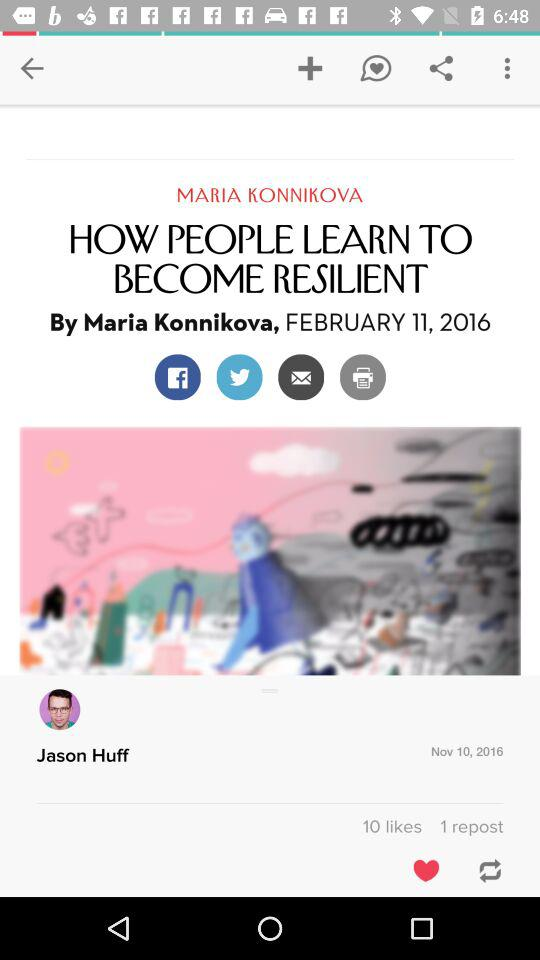How many more likes does the article have than reposts?
Answer the question using a single word or phrase. 9 